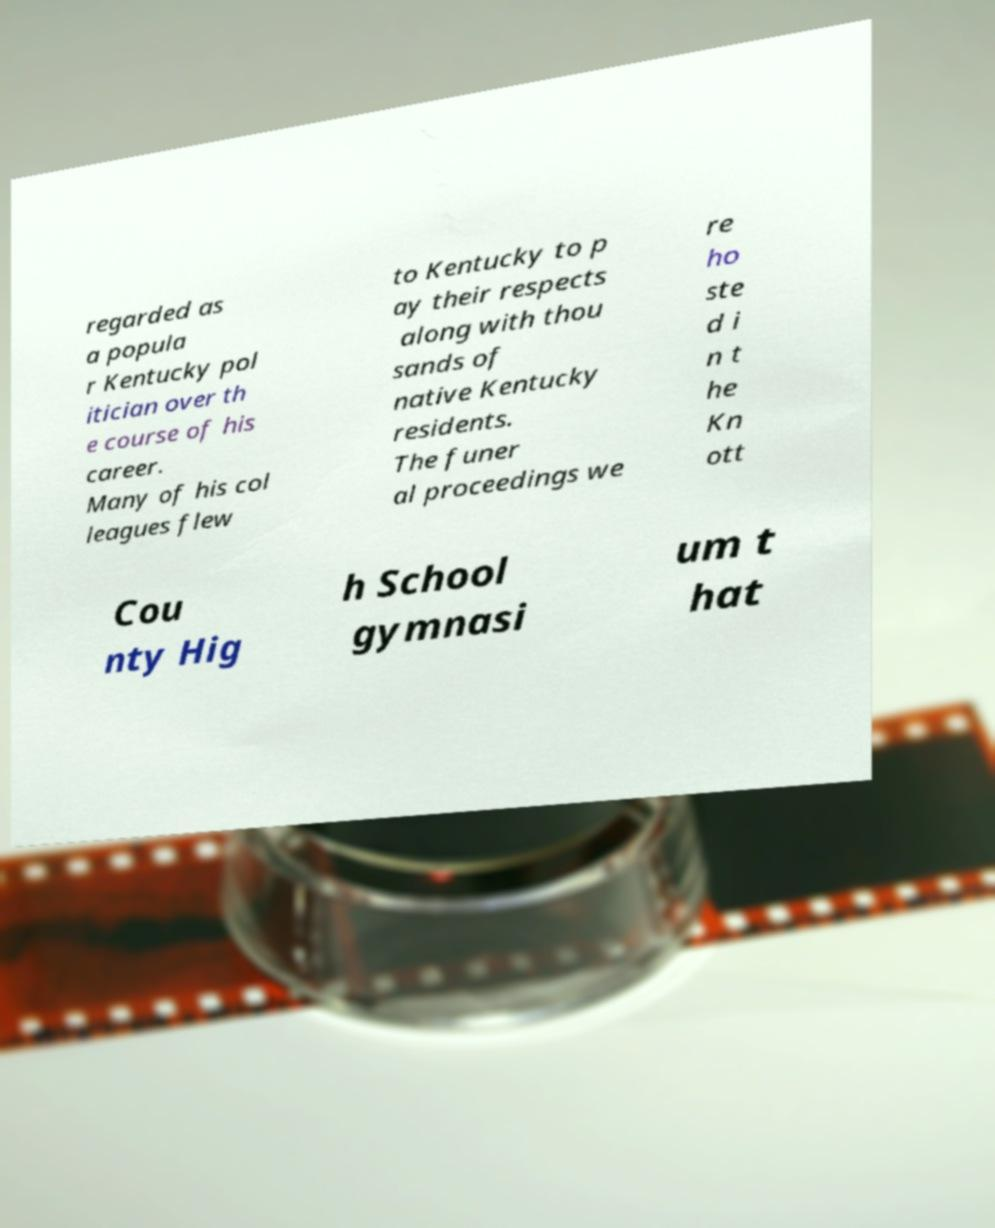Could you extract and type out the text from this image? regarded as a popula r Kentucky pol itician over th e course of his career. Many of his col leagues flew to Kentucky to p ay their respects along with thou sands of native Kentucky residents. The funer al proceedings we re ho ste d i n t he Kn ott Cou nty Hig h School gymnasi um t hat 